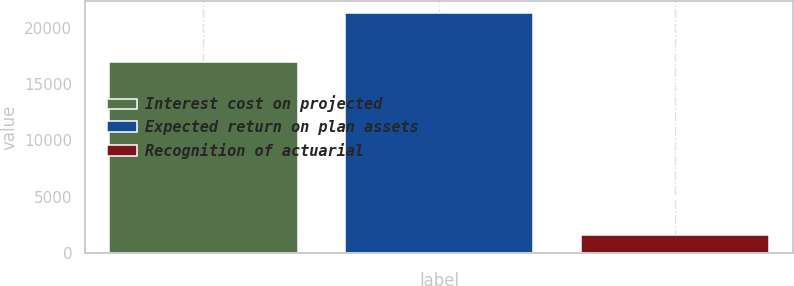Convert chart to OTSL. <chart><loc_0><loc_0><loc_500><loc_500><bar_chart><fcel>Interest cost on projected<fcel>Expected return on plan assets<fcel>Recognition of actuarial<nl><fcel>16980<fcel>21304<fcel>1620<nl></chart> 